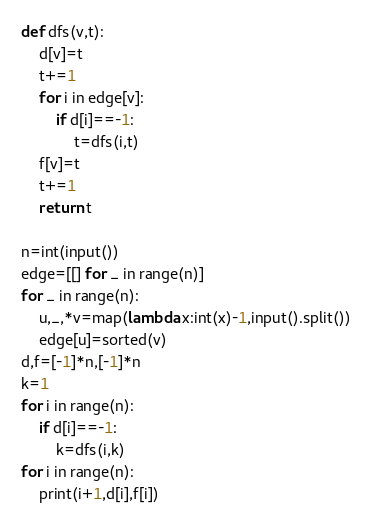<code> <loc_0><loc_0><loc_500><loc_500><_Python_>def dfs(v,t):
    d[v]=t
    t+=1
    for i in edge[v]:
        if d[i]==-1:
            t=dfs(i,t)
    f[v]=t
    t+=1
    return t

n=int(input())
edge=[[] for _ in range(n)]
for _ in range(n):
    u,_,*v=map(lambda x:int(x)-1,input().split())
    edge[u]=sorted(v)
d,f=[-1]*n,[-1]*n
k=1
for i in range(n):
    if d[i]==-1:
        k=dfs(i,k)
for i in range(n):
    print(i+1,d[i],f[i])

</code> 